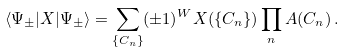<formula> <loc_0><loc_0><loc_500><loc_500>\langle \Psi _ { \pm } | X | \Psi _ { \pm } \rangle = \sum _ { \{ C _ { n } \} } ( \pm 1 ) ^ { W } X ( \{ C _ { n } \} ) \prod _ { n } A ( C _ { n } ) \, .</formula> 